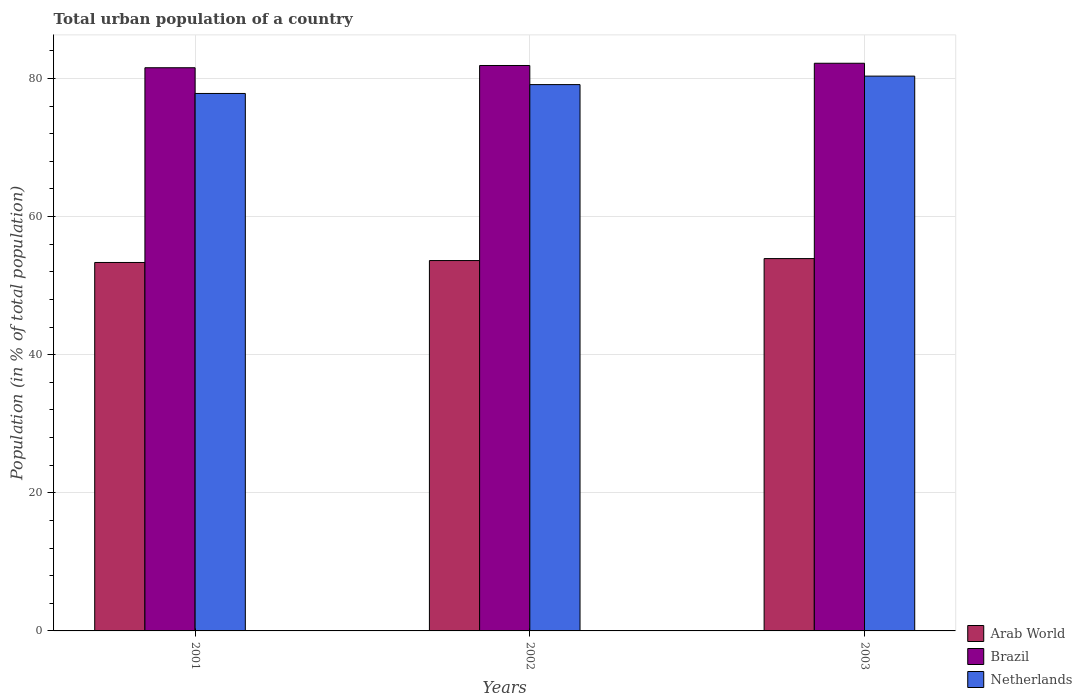How many different coloured bars are there?
Your answer should be very brief. 3. Are the number of bars per tick equal to the number of legend labels?
Offer a very short reply. Yes. How many bars are there on the 1st tick from the left?
Provide a succinct answer. 3. What is the label of the 1st group of bars from the left?
Keep it short and to the point. 2001. In how many cases, is the number of bars for a given year not equal to the number of legend labels?
Provide a succinct answer. 0. What is the urban population in Arab World in 2003?
Provide a succinct answer. 53.92. Across all years, what is the maximum urban population in Arab World?
Your answer should be compact. 53.92. Across all years, what is the minimum urban population in Netherlands?
Offer a terse response. 77.83. What is the total urban population in Netherlands in the graph?
Offer a very short reply. 237.28. What is the difference between the urban population in Netherlands in 2001 and that in 2003?
Make the answer very short. -2.51. What is the difference between the urban population in Netherlands in 2003 and the urban population in Brazil in 2001?
Give a very brief answer. -1.21. What is the average urban population in Arab World per year?
Your response must be concise. 53.64. In the year 2003, what is the difference between the urban population in Arab World and urban population in Brazil?
Provide a short and direct response. -28.29. In how many years, is the urban population in Arab World greater than 56 %?
Your answer should be very brief. 0. What is the ratio of the urban population in Brazil in 2001 to that in 2002?
Your answer should be very brief. 1. Is the urban population in Brazil in 2001 less than that in 2002?
Your answer should be compact. Yes. What is the difference between the highest and the second highest urban population in Brazil?
Your answer should be very brief. 0.32. What is the difference between the highest and the lowest urban population in Netherlands?
Your answer should be very brief. 2.51. In how many years, is the urban population in Arab World greater than the average urban population in Arab World taken over all years?
Give a very brief answer. 1. Is the sum of the urban population in Arab World in 2002 and 2003 greater than the maximum urban population in Brazil across all years?
Make the answer very short. Yes. What does the 1st bar from the left in 2003 represents?
Offer a terse response. Arab World. Is it the case that in every year, the sum of the urban population in Arab World and urban population in Netherlands is greater than the urban population in Brazil?
Offer a very short reply. Yes. How many bars are there?
Offer a very short reply. 9. How many years are there in the graph?
Provide a succinct answer. 3. What is the difference between two consecutive major ticks on the Y-axis?
Provide a short and direct response. 20. Are the values on the major ticks of Y-axis written in scientific E-notation?
Make the answer very short. No. Where does the legend appear in the graph?
Provide a short and direct response. Bottom right. What is the title of the graph?
Ensure brevity in your answer.  Total urban population of a country. Does "Spain" appear as one of the legend labels in the graph?
Your answer should be compact. No. What is the label or title of the X-axis?
Make the answer very short. Years. What is the label or title of the Y-axis?
Your answer should be very brief. Population (in % of total population). What is the Population (in % of total population) of Arab World in 2001?
Your response must be concise. 53.36. What is the Population (in % of total population) of Brazil in 2001?
Your answer should be compact. 81.55. What is the Population (in % of total population) of Netherlands in 2001?
Make the answer very short. 77.83. What is the Population (in % of total population) in Arab World in 2002?
Give a very brief answer. 53.63. What is the Population (in % of total population) in Brazil in 2002?
Give a very brief answer. 81.88. What is the Population (in % of total population) of Netherlands in 2002?
Give a very brief answer. 79.11. What is the Population (in % of total population) of Arab World in 2003?
Give a very brief answer. 53.92. What is the Population (in % of total population) of Brazil in 2003?
Keep it short and to the point. 82.2. What is the Population (in % of total population) in Netherlands in 2003?
Offer a very short reply. 80.34. Across all years, what is the maximum Population (in % of total population) of Arab World?
Ensure brevity in your answer.  53.92. Across all years, what is the maximum Population (in % of total population) of Brazil?
Your answer should be very brief. 82.2. Across all years, what is the maximum Population (in % of total population) in Netherlands?
Make the answer very short. 80.34. Across all years, what is the minimum Population (in % of total population) of Arab World?
Offer a terse response. 53.36. Across all years, what is the minimum Population (in % of total population) in Brazil?
Your response must be concise. 81.55. Across all years, what is the minimum Population (in % of total population) of Netherlands?
Offer a very short reply. 77.83. What is the total Population (in % of total population) of Arab World in the graph?
Provide a succinct answer. 160.91. What is the total Population (in % of total population) in Brazil in the graph?
Provide a succinct answer. 245.64. What is the total Population (in % of total population) in Netherlands in the graph?
Make the answer very short. 237.28. What is the difference between the Population (in % of total population) in Arab World in 2001 and that in 2002?
Offer a terse response. -0.28. What is the difference between the Population (in % of total population) of Brazil in 2001 and that in 2002?
Ensure brevity in your answer.  -0.33. What is the difference between the Population (in % of total population) in Netherlands in 2001 and that in 2002?
Make the answer very short. -1.28. What is the difference between the Population (in % of total population) of Arab World in 2001 and that in 2003?
Your answer should be very brief. -0.56. What is the difference between the Population (in % of total population) in Brazil in 2001 and that in 2003?
Ensure brevity in your answer.  -0.65. What is the difference between the Population (in % of total population) of Netherlands in 2001 and that in 2003?
Give a very brief answer. -2.51. What is the difference between the Population (in % of total population) in Arab World in 2002 and that in 2003?
Offer a terse response. -0.28. What is the difference between the Population (in % of total population) of Brazil in 2002 and that in 2003?
Keep it short and to the point. -0.32. What is the difference between the Population (in % of total population) in Netherlands in 2002 and that in 2003?
Your response must be concise. -1.23. What is the difference between the Population (in % of total population) in Arab World in 2001 and the Population (in % of total population) in Brazil in 2002?
Your answer should be very brief. -28.52. What is the difference between the Population (in % of total population) in Arab World in 2001 and the Population (in % of total population) in Netherlands in 2002?
Give a very brief answer. -25.76. What is the difference between the Population (in % of total population) of Brazil in 2001 and the Population (in % of total population) of Netherlands in 2002?
Your answer should be compact. 2.44. What is the difference between the Population (in % of total population) in Arab World in 2001 and the Population (in % of total population) in Brazil in 2003?
Provide a short and direct response. -28.85. What is the difference between the Population (in % of total population) of Arab World in 2001 and the Population (in % of total population) of Netherlands in 2003?
Keep it short and to the point. -26.99. What is the difference between the Population (in % of total population) in Brazil in 2001 and the Population (in % of total population) in Netherlands in 2003?
Make the answer very short. 1.21. What is the difference between the Population (in % of total population) of Arab World in 2002 and the Population (in % of total population) of Brazil in 2003?
Make the answer very short. -28.57. What is the difference between the Population (in % of total population) in Arab World in 2002 and the Population (in % of total population) in Netherlands in 2003?
Provide a short and direct response. -26.71. What is the difference between the Population (in % of total population) in Brazil in 2002 and the Population (in % of total population) in Netherlands in 2003?
Ensure brevity in your answer.  1.54. What is the average Population (in % of total population) of Arab World per year?
Provide a succinct answer. 53.64. What is the average Population (in % of total population) of Brazil per year?
Offer a very short reply. 81.88. What is the average Population (in % of total population) of Netherlands per year?
Provide a short and direct response. 79.09. In the year 2001, what is the difference between the Population (in % of total population) in Arab World and Population (in % of total population) in Brazil?
Ensure brevity in your answer.  -28.2. In the year 2001, what is the difference between the Population (in % of total population) of Arab World and Population (in % of total population) of Netherlands?
Your answer should be compact. -24.47. In the year 2001, what is the difference between the Population (in % of total population) of Brazil and Population (in % of total population) of Netherlands?
Make the answer very short. 3.72. In the year 2002, what is the difference between the Population (in % of total population) in Arab World and Population (in % of total population) in Brazil?
Your answer should be very brief. -28.25. In the year 2002, what is the difference between the Population (in % of total population) in Arab World and Population (in % of total population) in Netherlands?
Make the answer very short. -25.48. In the year 2002, what is the difference between the Population (in % of total population) in Brazil and Population (in % of total population) in Netherlands?
Your response must be concise. 2.77. In the year 2003, what is the difference between the Population (in % of total population) of Arab World and Population (in % of total population) of Brazil?
Offer a very short reply. -28.29. In the year 2003, what is the difference between the Population (in % of total population) of Arab World and Population (in % of total population) of Netherlands?
Your answer should be very brief. -26.42. In the year 2003, what is the difference between the Population (in % of total population) in Brazil and Population (in % of total population) in Netherlands?
Your answer should be very brief. 1.86. What is the ratio of the Population (in % of total population) in Brazil in 2001 to that in 2002?
Give a very brief answer. 1. What is the ratio of the Population (in % of total population) of Netherlands in 2001 to that in 2002?
Your answer should be compact. 0.98. What is the ratio of the Population (in % of total population) in Arab World in 2001 to that in 2003?
Ensure brevity in your answer.  0.99. What is the ratio of the Population (in % of total population) of Netherlands in 2001 to that in 2003?
Keep it short and to the point. 0.97. What is the ratio of the Population (in % of total population) in Arab World in 2002 to that in 2003?
Ensure brevity in your answer.  0.99. What is the ratio of the Population (in % of total population) in Netherlands in 2002 to that in 2003?
Offer a terse response. 0.98. What is the difference between the highest and the second highest Population (in % of total population) in Arab World?
Provide a succinct answer. 0.28. What is the difference between the highest and the second highest Population (in % of total population) of Brazil?
Make the answer very short. 0.32. What is the difference between the highest and the second highest Population (in % of total population) of Netherlands?
Your answer should be very brief. 1.23. What is the difference between the highest and the lowest Population (in % of total population) in Arab World?
Offer a terse response. 0.56. What is the difference between the highest and the lowest Population (in % of total population) of Brazil?
Offer a very short reply. 0.65. What is the difference between the highest and the lowest Population (in % of total population) in Netherlands?
Give a very brief answer. 2.51. 